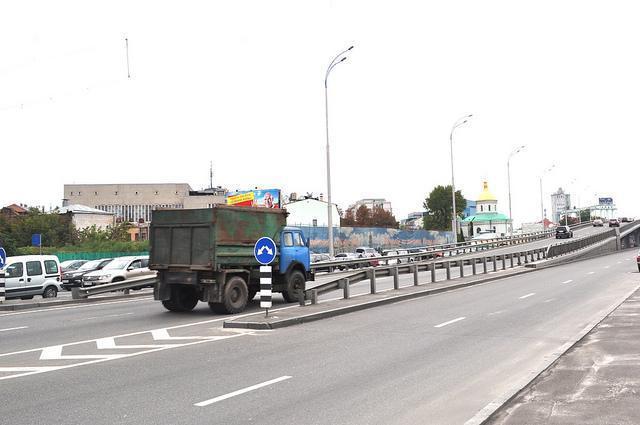How many tracks are displayed?
Give a very brief answer. 0. How many cars are there?
Give a very brief answer. 2. How many people are there?
Give a very brief answer. 0. 